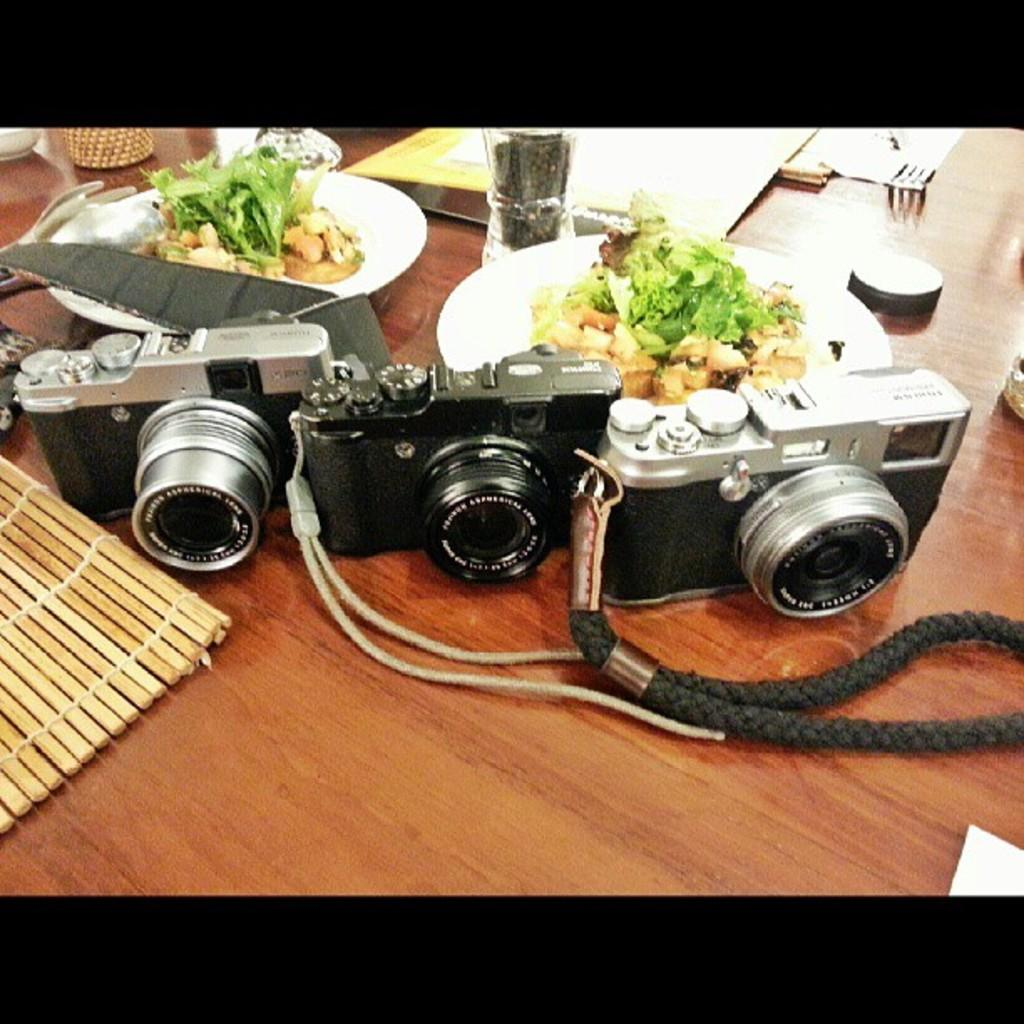What is the main piece of furniture in the image? There is a table in the image. What objects related to photography can be seen on the table? There are three cameras on the table. What type of food is present on the table? There are two plates containing food on the table. What is the only beverage container on the table? There is one glass on the table. What utensil is available for eating on the table? There is one fork on the table. What type of paper items are on the table? There are some papers on the table. What type of action is the potato performing in the image? There is no potato present in the image, so it cannot perform any actions. 